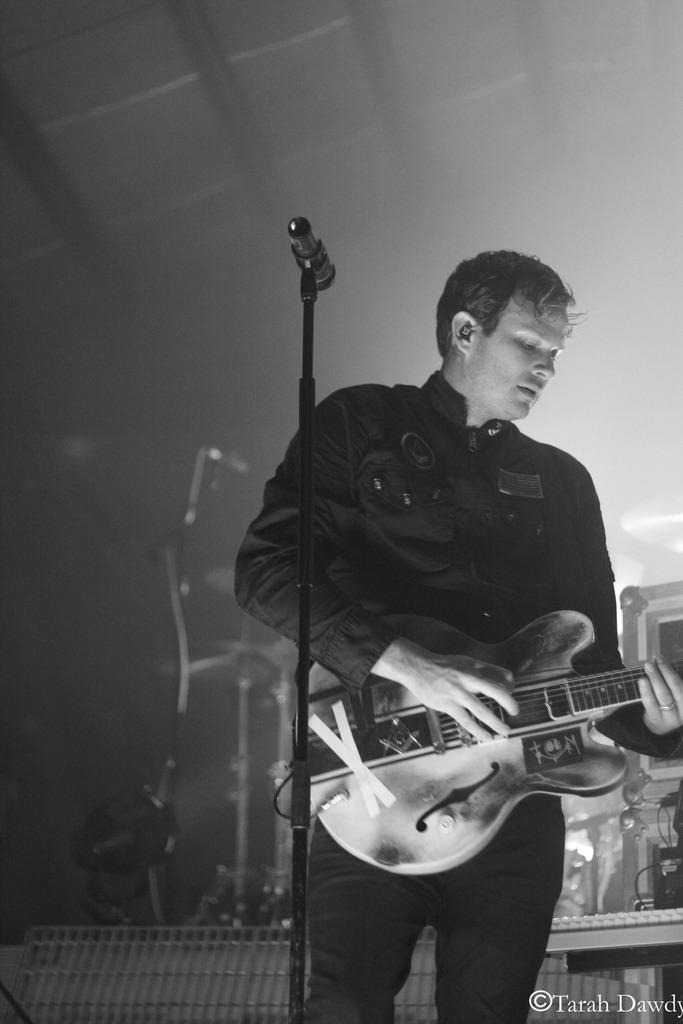Who is the main subject in the image? There is a man in the image. Where is the man positioned in the image? The man is standing in the middle. What is the man holding in his hand? The man is holding a guitar in his hand. What other object can be seen in the image? There is a microphone in the image. What is the color of the stand in the image? There is a black-colored stand in the image. What type of vegetable is being used as a prop in the image? There is no vegetable present in the image; it features a man holding a guitar and standing near a microphone and black-colored stand. 